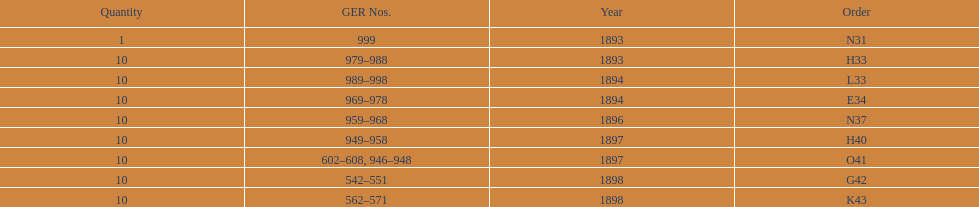How many years are enumerated? 5. 